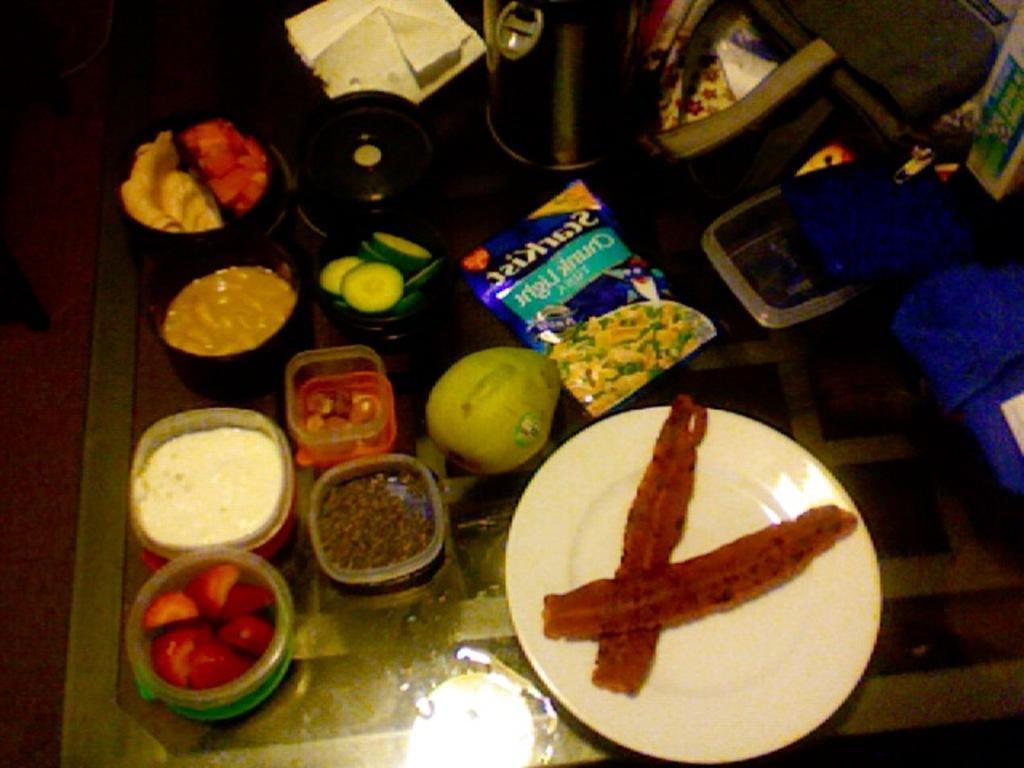In one or two sentences, can you explain what this image depicts? This image consists of foods which is in the center, on the table. On the right side there are objects which are blue in colour and on the top there is a flask and a paper. 